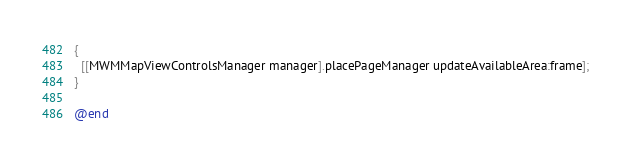Convert code to text. <code><loc_0><loc_0><loc_500><loc_500><_ObjectiveC_>{
  [[MWMMapViewControlsManager manager].placePageManager updateAvailableArea:frame];
}

@end
</code> 